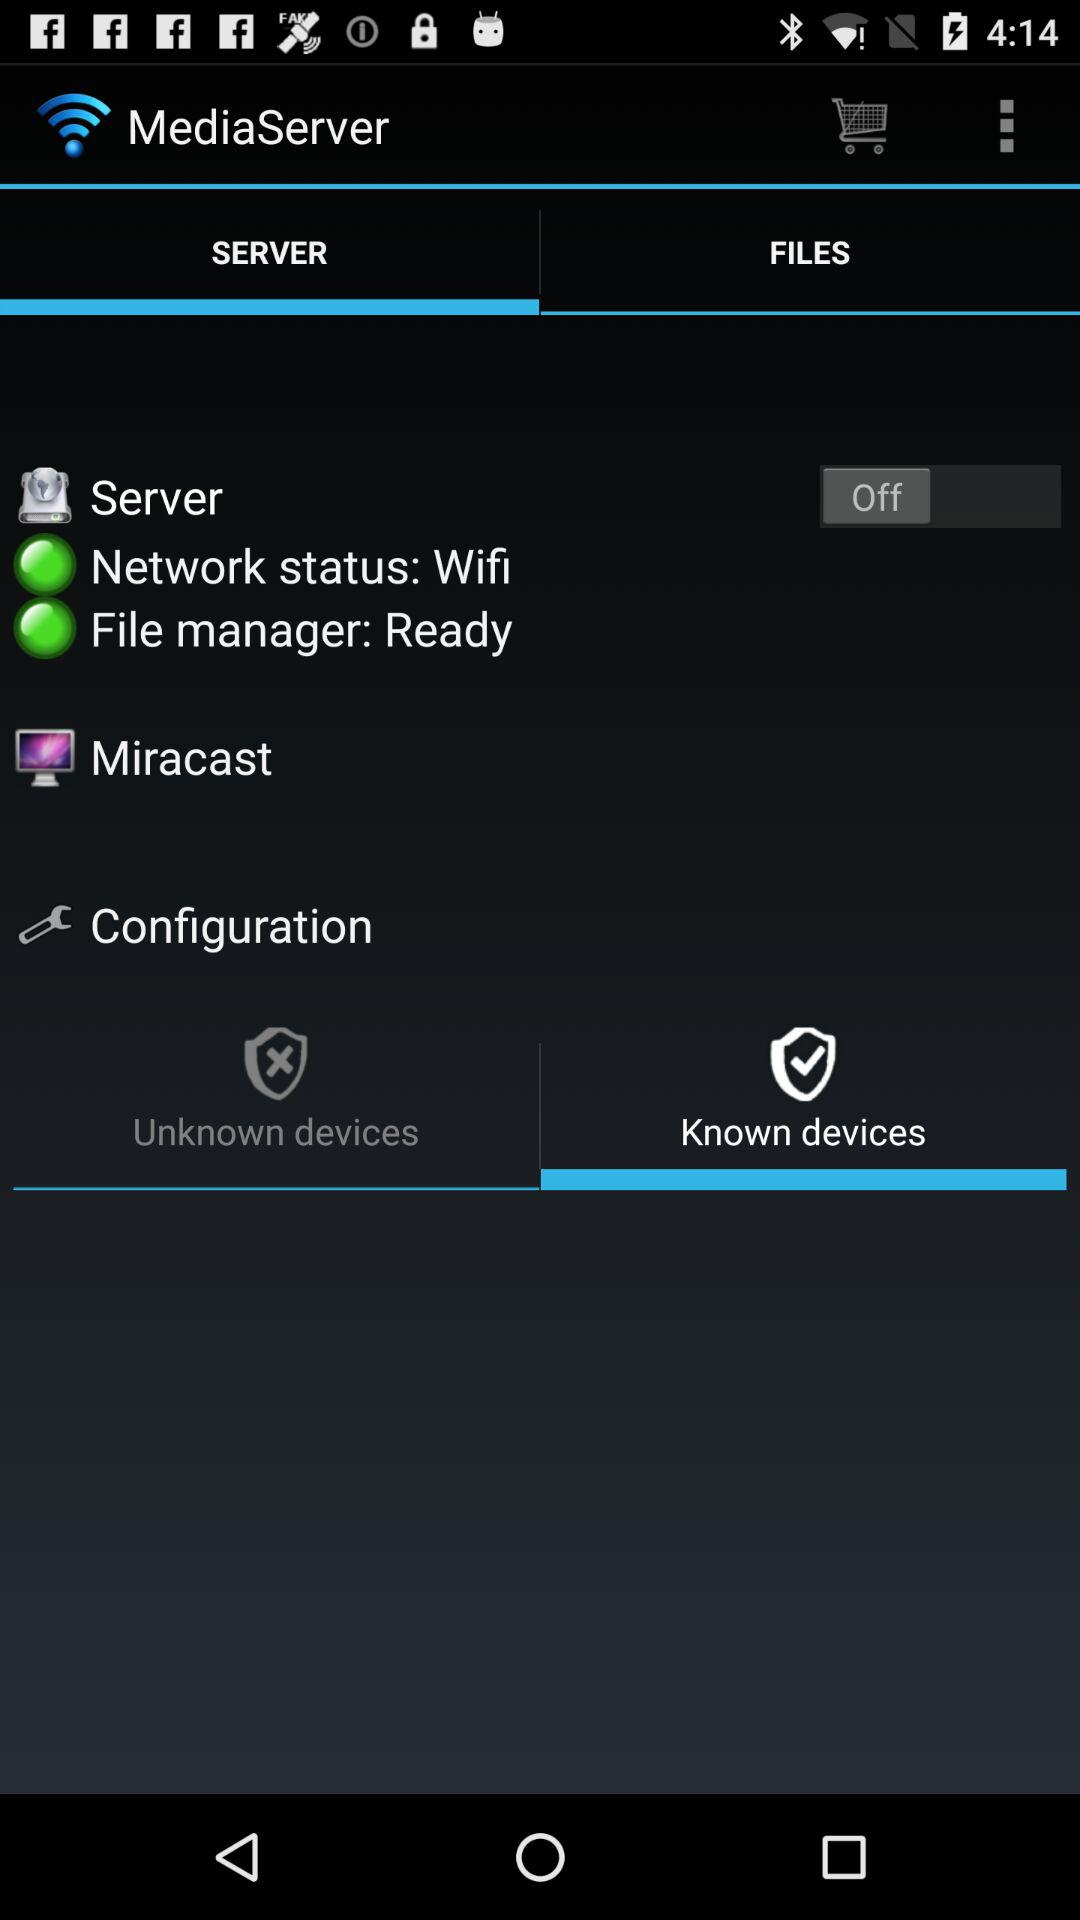What is the status of the "Server"? The status of the "Server" is "Off". 